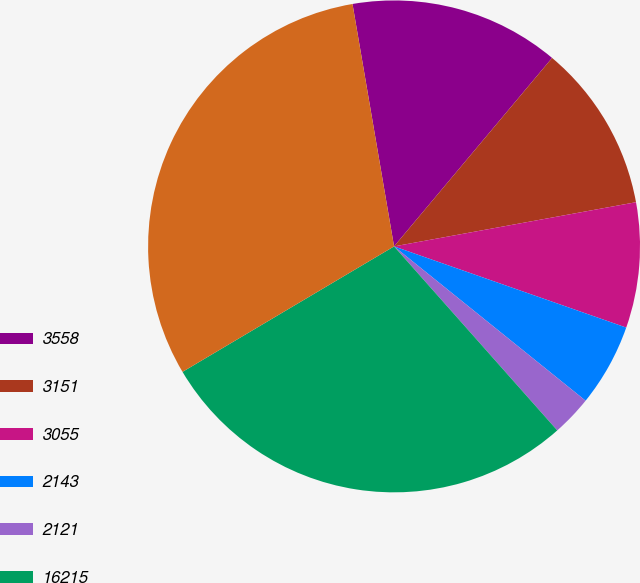<chart> <loc_0><loc_0><loc_500><loc_500><pie_chart><fcel>3558<fcel>3151<fcel>3055<fcel>2143<fcel>2121<fcel>16215<fcel>17369<nl><fcel>13.81%<fcel>11.02%<fcel>8.23%<fcel>5.44%<fcel>2.66%<fcel>28.03%<fcel>30.82%<nl></chart> 